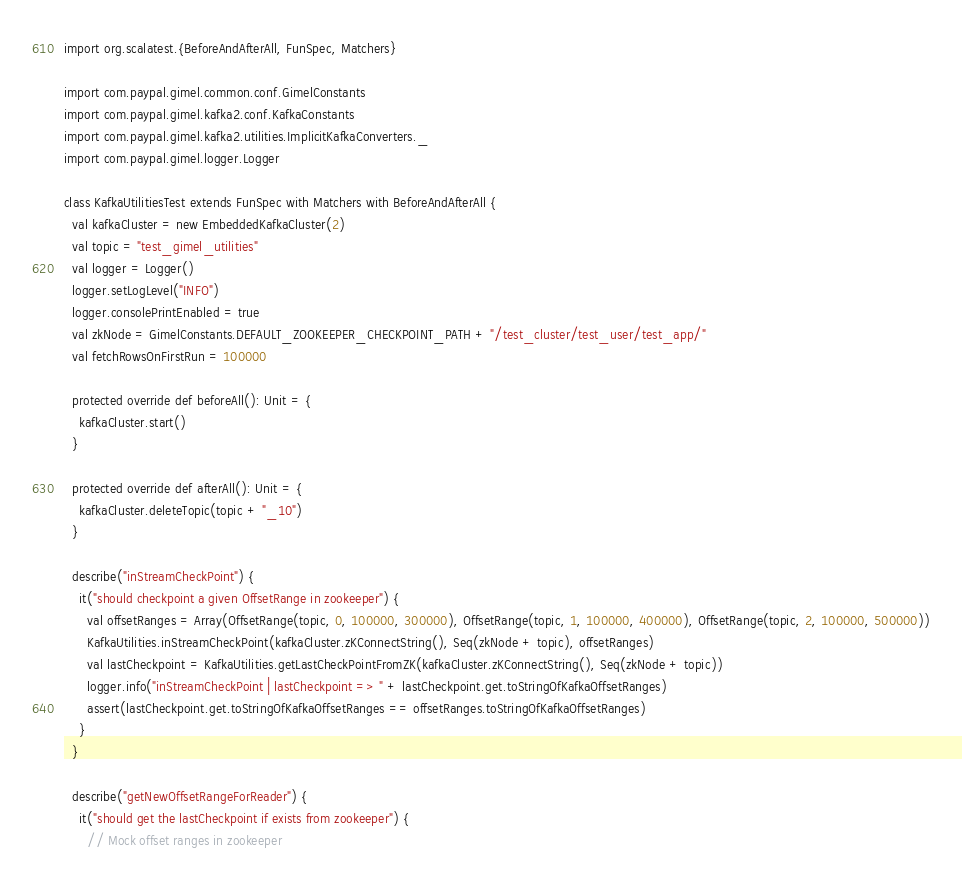Convert code to text. <code><loc_0><loc_0><loc_500><loc_500><_Scala_>import org.scalatest.{BeforeAndAfterAll, FunSpec, Matchers}

import com.paypal.gimel.common.conf.GimelConstants
import com.paypal.gimel.kafka2.conf.KafkaConstants
import com.paypal.gimel.kafka2.utilities.ImplicitKafkaConverters._
import com.paypal.gimel.logger.Logger

class KafkaUtilitiesTest extends FunSpec with Matchers with BeforeAndAfterAll {
  val kafkaCluster = new EmbeddedKafkaCluster(2)
  val topic = "test_gimel_utilities"
  val logger = Logger()
  logger.setLogLevel("INFO")
  logger.consolePrintEnabled = true
  val zkNode = GimelConstants.DEFAULT_ZOOKEEPER_CHECKPOINT_PATH + "/test_cluster/test_user/test_app/"
  val fetchRowsOnFirstRun = 100000

  protected override def beforeAll(): Unit = {
    kafkaCluster.start()
  }

  protected override def afterAll(): Unit = {
    kafkaCluster.deleteTopic(topic + "_10")
  }

  describe("inStreamCheckPoint") {
    it("should checkpoint a given OffsetRange in zookeeper") {
      val offsetRanges = Array(OffsetRange(topic, 0, 100000, 300000), OffsetRange(topic, 1, 100000, 400000), OffsetRange(topic, 2, 100000, 500000))
      KafkaUtilities.inStreamCheckPoint(kafkaCluster.zKConnectString(), Seq(zkNode + topic), offsetRanges)
      val lastCheckpoint = KafkaUtilities.getLastCheckPointFromZK(kafkaCluster.zKConnectString(), Seq(zkNode + topic))
      logger.info("inStreamCheckPoint | lastCheckpoint => " + lastCheckpoint.get.toStringOfKafkaOffsetRanges)
      assert(lastCheckpoint.get.toStringOfKafkaOffsetRanges == offsetRanges.toStringOfKafkaOffsetRanges)
    }
  }

  describe("getNewOffsetRangeForReader") {
    it("should get the lastCheckpoint if exists from zookeeper") {
      // Mock offset ranges in zookeeper</code> 